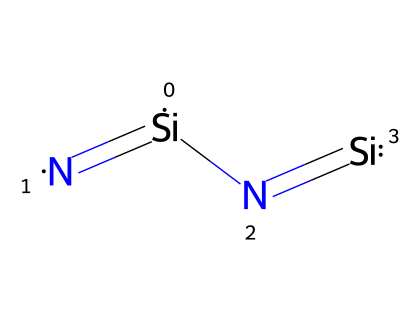What is the central atom in this chemical structure? In the provided SMILES representation, silicon (Si) appears as the main atom at the center of the structure, surrounded by nitrogen (N) atoms. Therefore, the central atom is silicon.
Answer: silicon How many nitrogen atoms are present in the molecule? By analyzing the SMILES representation, we can see there are two nitrogen atoms (N) bonded to the silicon atoms (Si) in the structure.
Answer: two What type of bonding is predominantly seen in this structure? The structure features multiple bonds between silicon and nitrogen, specifically double bonds, indicating that the primary bonding type in this chemical is covalent bonding.
Answer: covalent What is the coordination number of silicon in this molecule? Silicon in this structure is bonded to two nitrogen atoms, which gives it a coordination number of 2. This represents how many atoms are directly bonded to the silicon atom.
Answer: two Does this chemical contain any hydroxyl (–OH) groups? Examining the SMILES representation reveals that there are no hydroxyl groups (–OH) present, as the structure consists solely of silicon and nitrogen atoms.
Answer: no What type of ceramics is this compound likely associated with? This compound, with its silicon-nitride framework, is typically associated with advanced ceramics, specifically in applications like durable ceramic microphones due to its mechanical strength and thermal stability.
Answer: advanced ceramics What is the approximate ratio of silicon to nitrogen in this compound? From the structure, we can deduce that for every silicon atom, there are two nitrogen atoms, resulting in a ratio of silicon to nitrogen of 1:2.
Answer: 1:2 